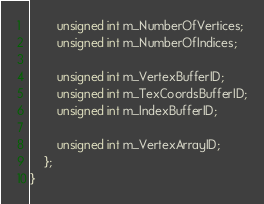<code> <loc_0><loc_0><loc_500><loc_500><_C_>		unsigned int m_NumberOfVertices;
		unsigned int m_NumberOfIndices;

		unsigned int m_VertexBufferID;
		unsigned int m_TexCoordsBufferID;
		unsigned int m_IndexBufferID;

		unsigned int m_VertexArrayID;
	};
}</code> 